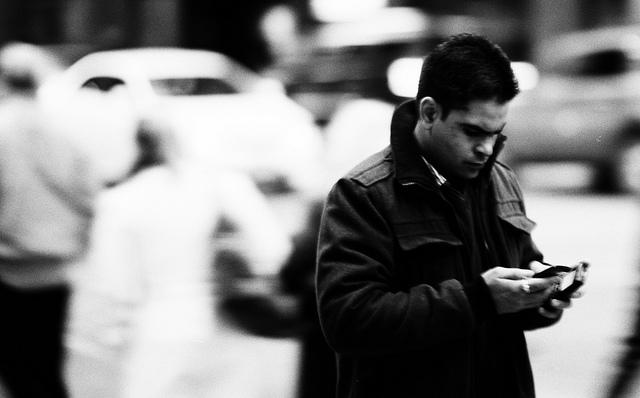Is the background in focus?
Keep it brief. No. Is the man looking up?
Concise answer only. No. Is this a nighttime picture?
Keep it brief. No. What is one possible danger from this person's activity?
Concise answer only. Car accident. 